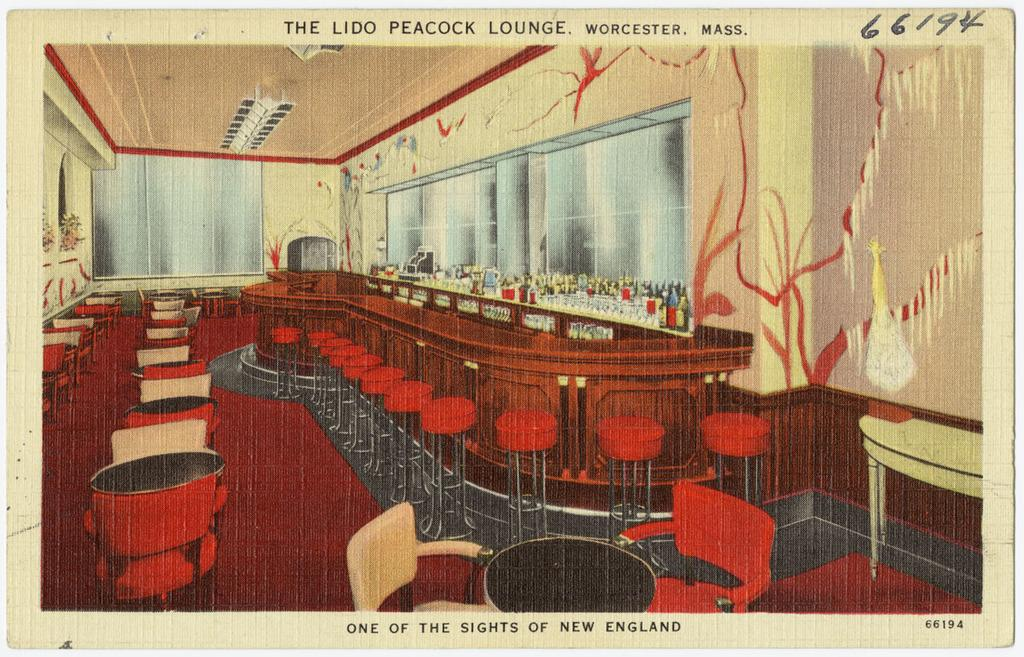What is present on the poster in the image? There is text in the image. Can you describe the poster in the image? There is a poster in the image, and it contains text. What type of pie is being served on the throne in the image? There is no pie or throne present in the image; it only features a poster with text. 